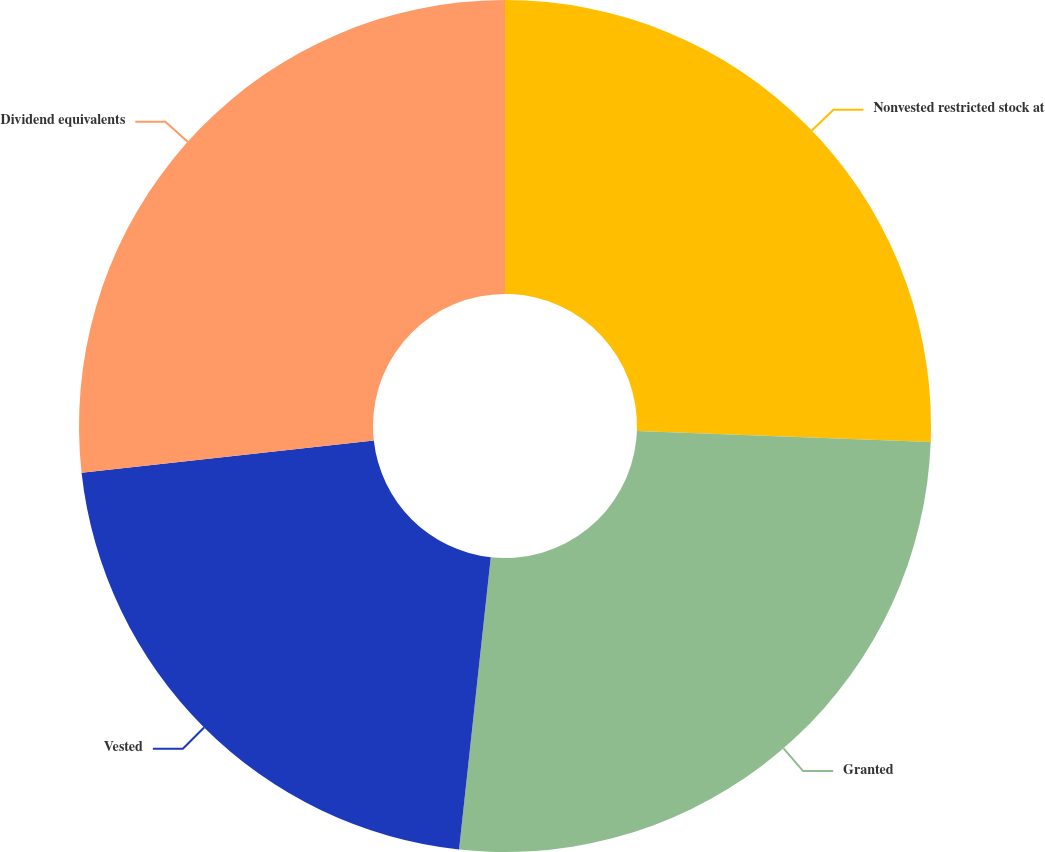<chart> <loc_0><loc_0><loc_500><loc_500><pie_chart><fcel>Nonvested restricted stock at<fcel>Granted<fcel>Vested<fcel>Dividend equivalents<nl><fcel>25.6%<fcel>26.12%<fcel>21.53%<fcel>26.75%<nl></chart> 